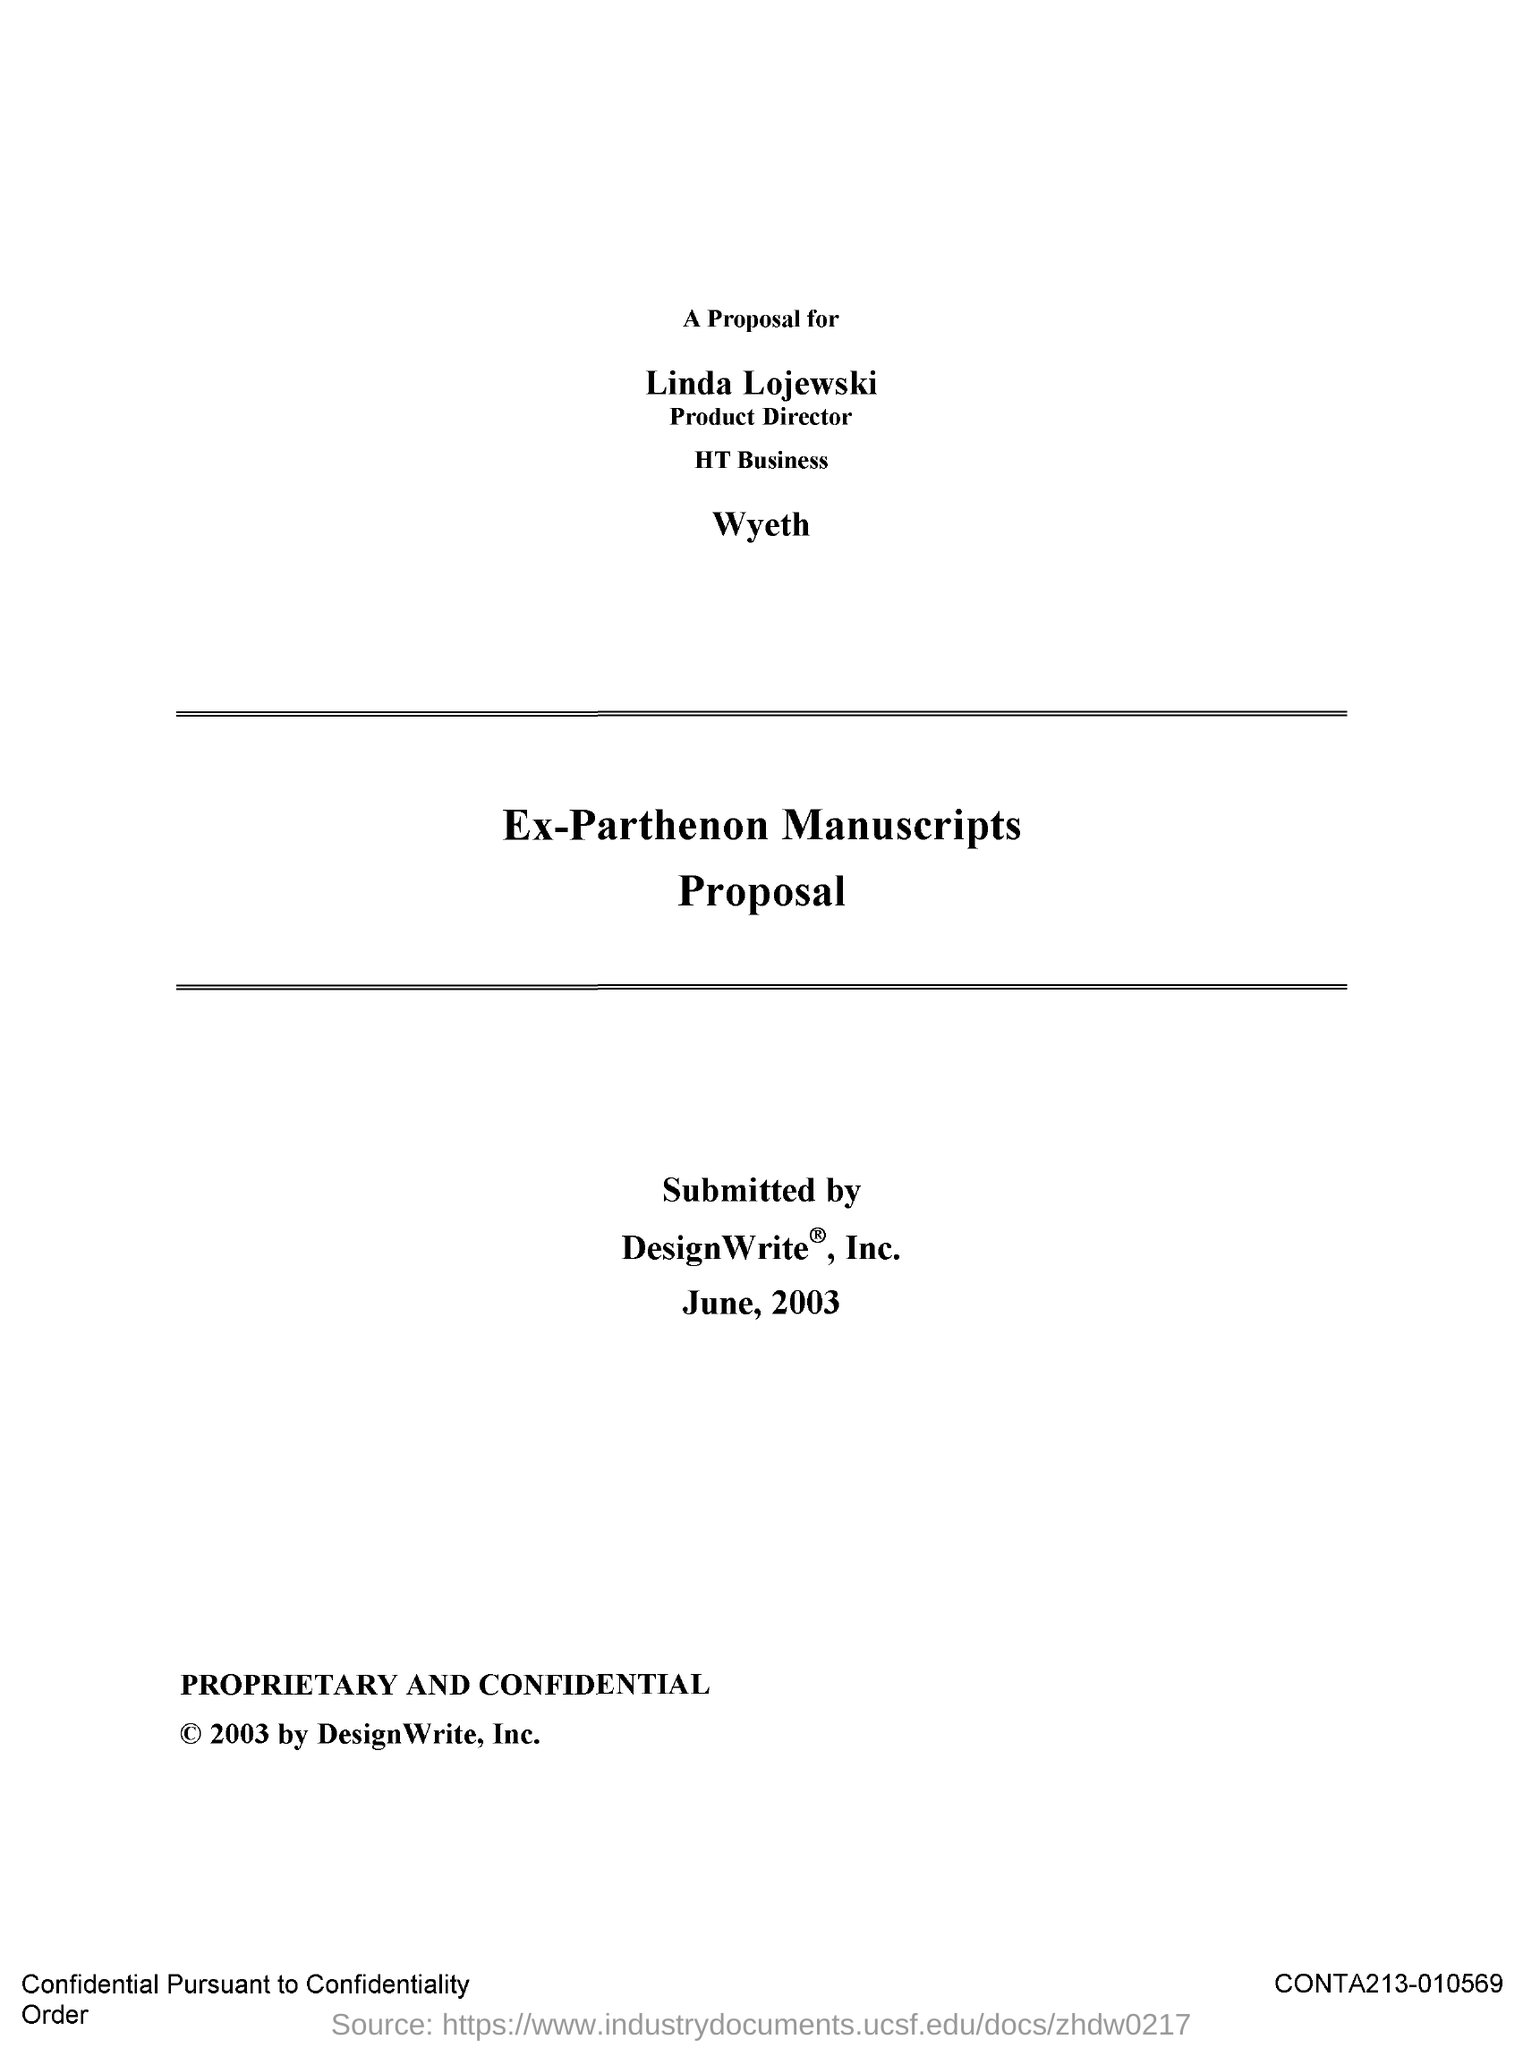Draw attention to some important aspects in this diagram. This proposal is presented to Linda Lojewski, who holds the position of Product Director. The date of submission is June 2003. The proposed action is intended for Linda Lojewski. The submission was made by Designwrite, Inc. 